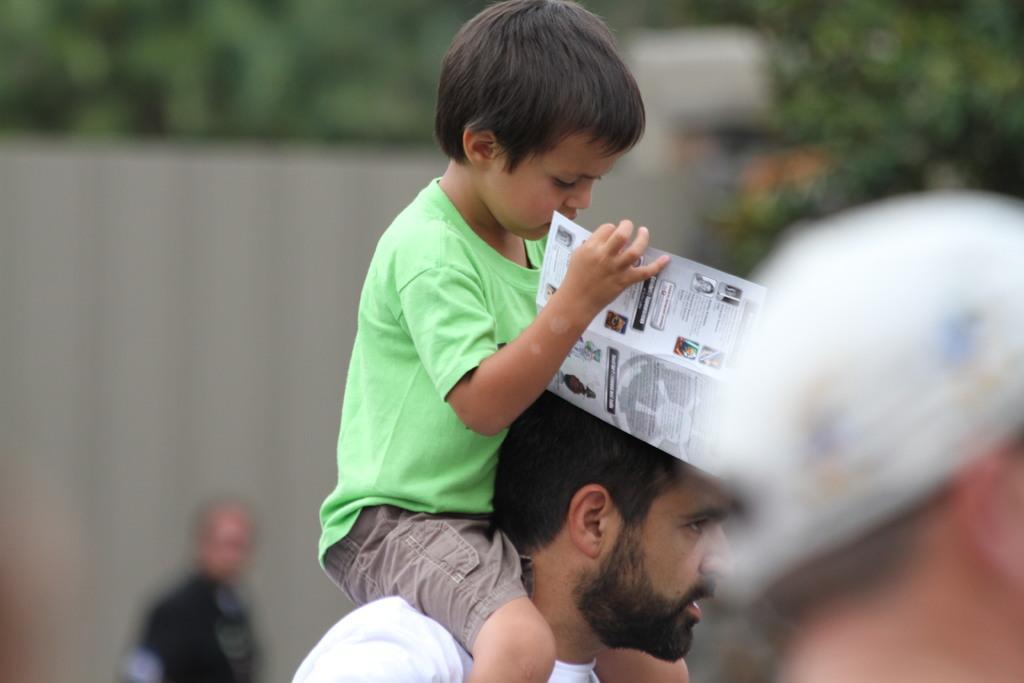Could you give a brief overview of what you see in this image? In the foreground of this image, on the right, there is a person. in the middle, there is a boy holding a paper and sitting on the shoulders of a man. In the background, there is another person, wall and the trees. 